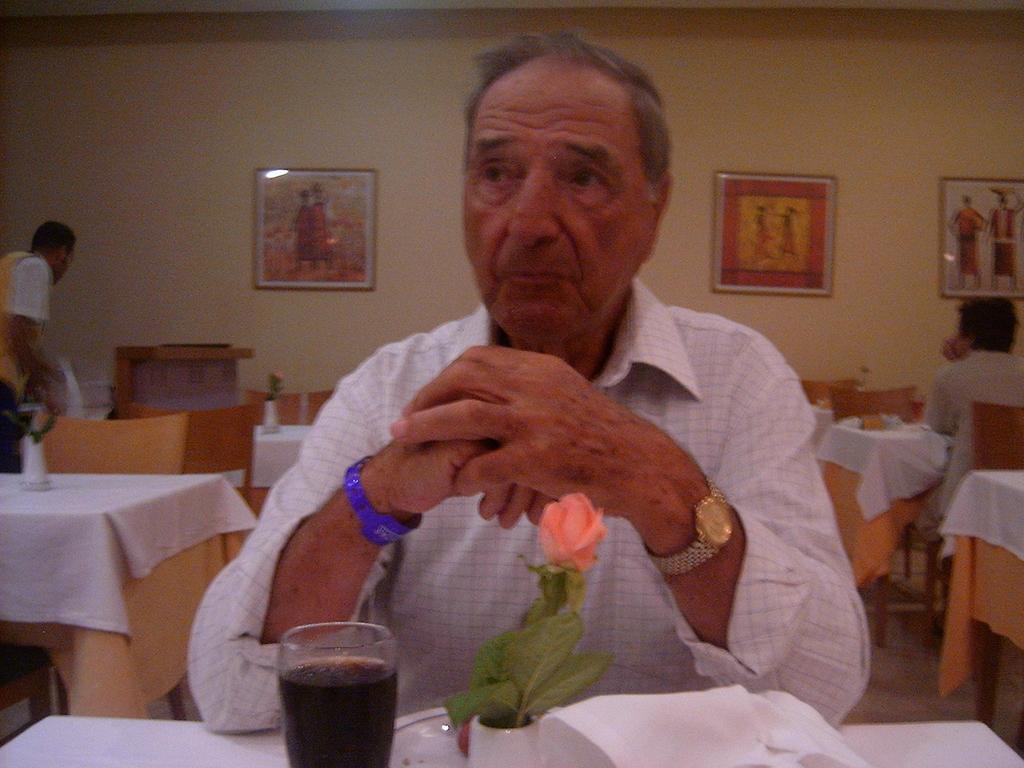Could you give a brief overview of what you see in this image? In this image I can see a man wearing white color shirt and sitting beside the table On this table I can see a flower pot, glass and some papers. In the background there is a wall and few frames are attached to it. On the right and the left sides of the image there are few tables covered with white clothes. On the right side there is a man sitting on the chair. On the left side there is a man standing. 